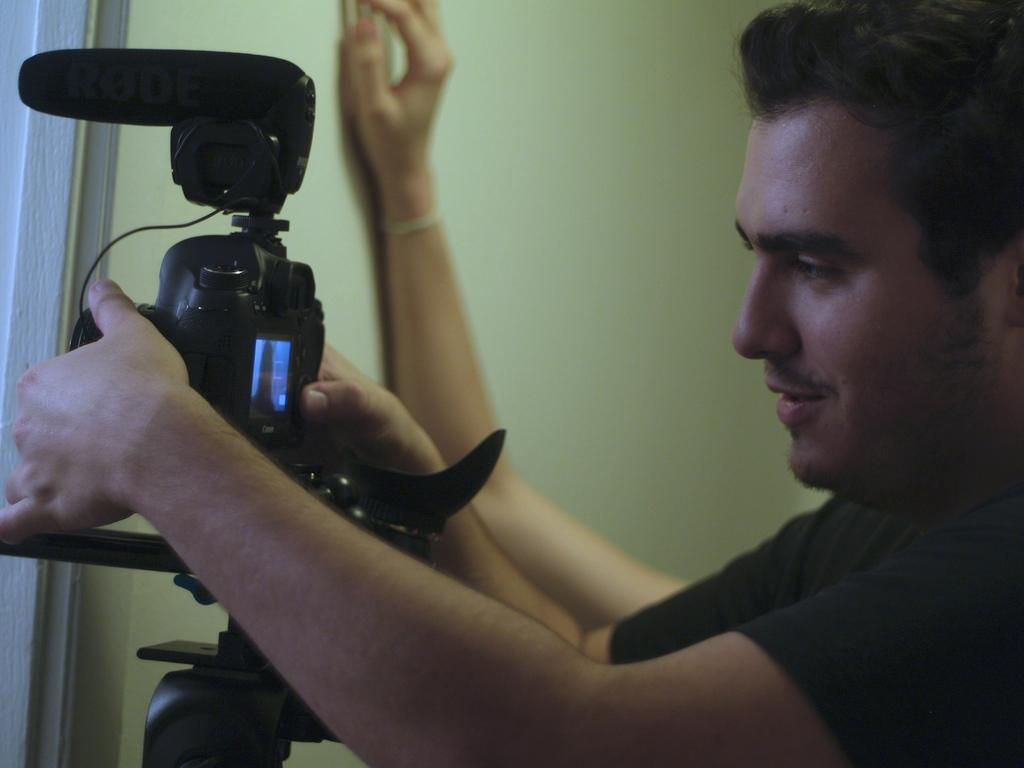What is the man in the image doing? The man is holding a camera in his hand. What is the man's facial expression in the image? The man is smiling. Can you describe anything in the background of the image? There is a wall in the background, and a hand of a person is visible. What type of plant is the goat eating in the image? There is no goat or plant present in the image; it features a man holding a camera and smiling. 